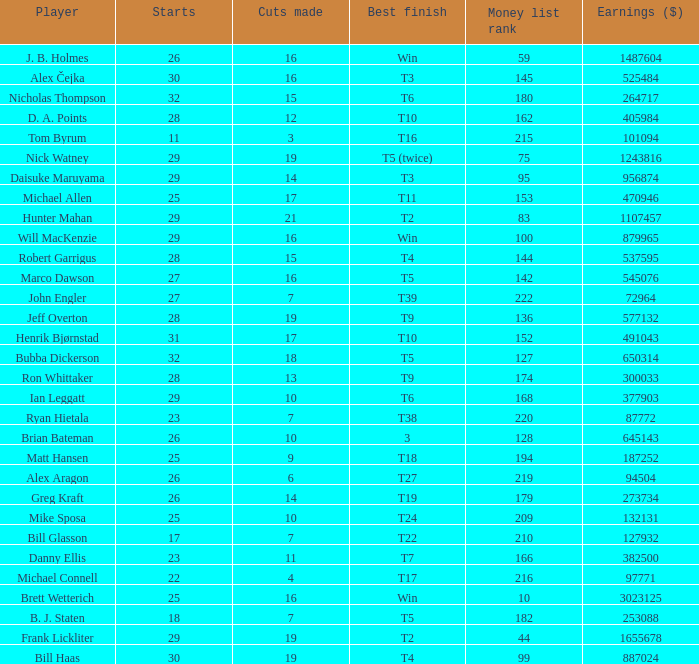What is the minimum financial position for players achieving a best finish of t9? 136.0. 